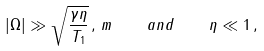Convert formula to latex. <formula><loc_0><loc_0><loc_500><loc_500>| \Omega | \gg \sqrt { \frac { \gamma \eta } { T _ { 1 } } } \, , \, m \quad a n d \quad \eta \ll 1 \, ,</formula> 